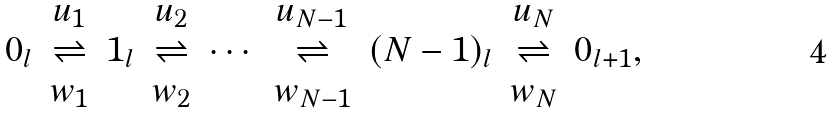Convert formula to latex. <formula><loc_0><loc_0><loc_500><loc_500>\begin{array} { c c c c c c c c c } & u _ { 1 } & & u _ { 2 } & & u _ { N - 1 } & & u _ { N } & \\ 0 _ { l } & \rightleftharpoons & 1 _ { l } & \rightleftharpoons & \cdots & \rightleftharpoons & ( N - 1 ) _ { l } & \rightleftharpoons & 0 _ { l + 1 } , \\ & w _ { 1 } & & w _ { 2 } & & w _ { N - 1 } & & w _ { N } & \end{array}</formula> 